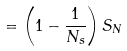Convert formula to latex. <formula><loc_0><loc_0><loc_500><loc_500>= \left ( 1 - \frac { 1 } { N _ { s } } \right ) S _ { N }</formula> 